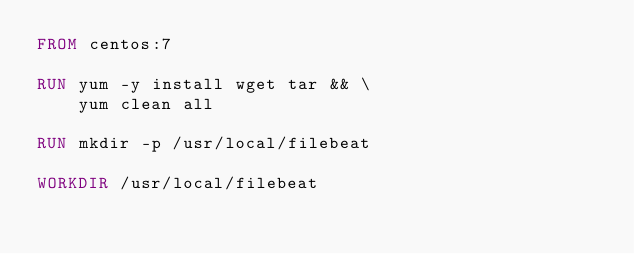Convert code to text. <code><loc_0><loc_0><loc_500><loc_500><_Dockerfile_>FROM centos:7

RUN yum -y install wget tar && \
    yum clean all

RUN mkdir -p /usr/local/filebeat

WORKDIR /usr/local/filebeat
</code> 